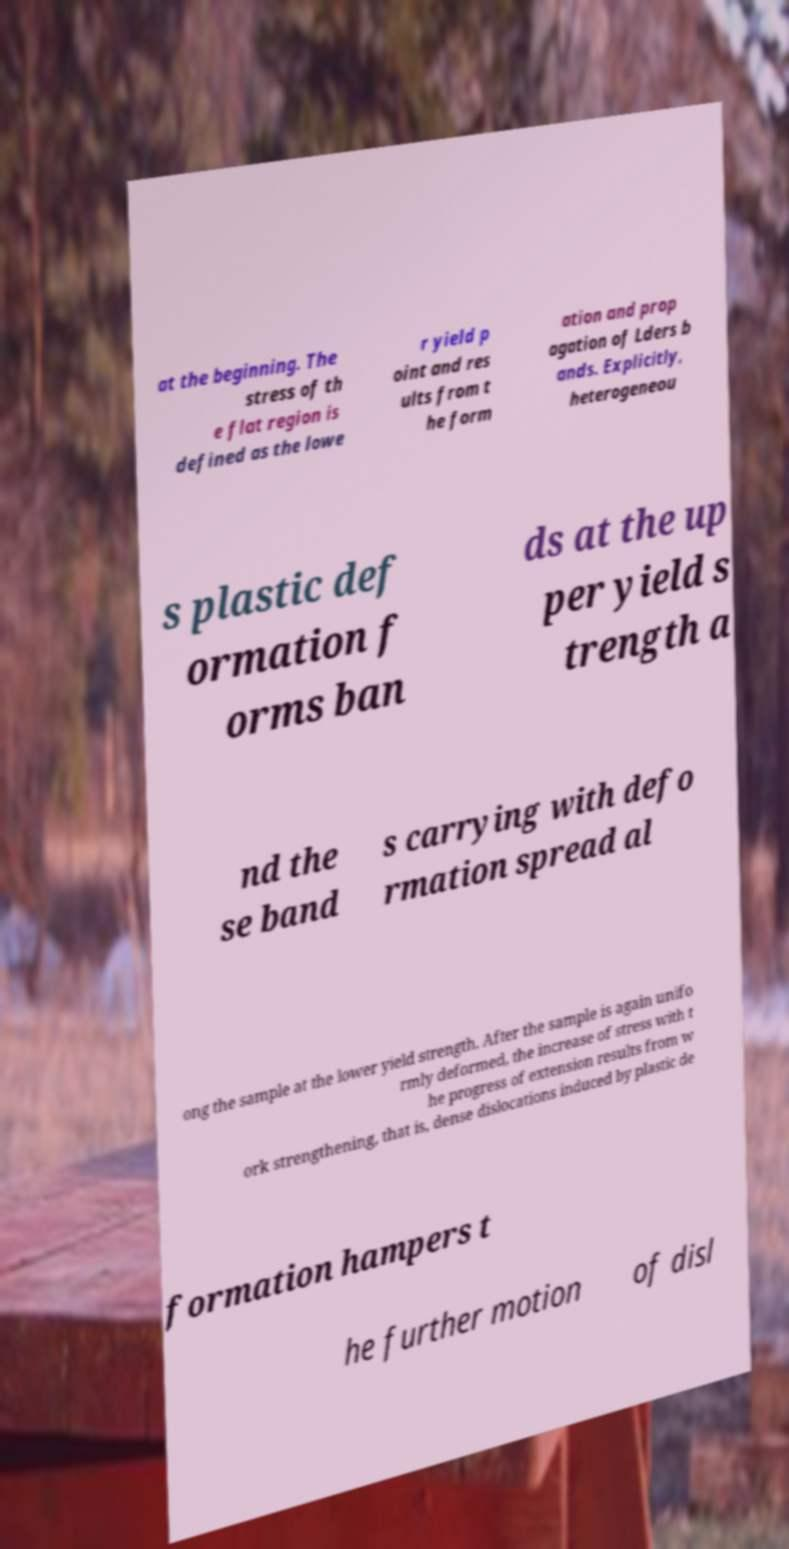There's text embedded in this image that I need extracted. Can you transcribe it verbatim? at the beginning. The stress of th e flat region is defined as the lowe r yield p oint and res ults from t he form ation and prop agation of Lders b ands. Explicitly, heterogeneou s plastic def ormation f orms ban ds at the up per yield s trength a nd the se band s carrying with defo rmation spread al ong the sample at the lower yield strength. After the sample is again unifo rmly deformed, the increase of stress with t he progress of extension results from w ork strengthening, that is, dense dislocations induced by plastic de formation hampers t he further motion of disl 